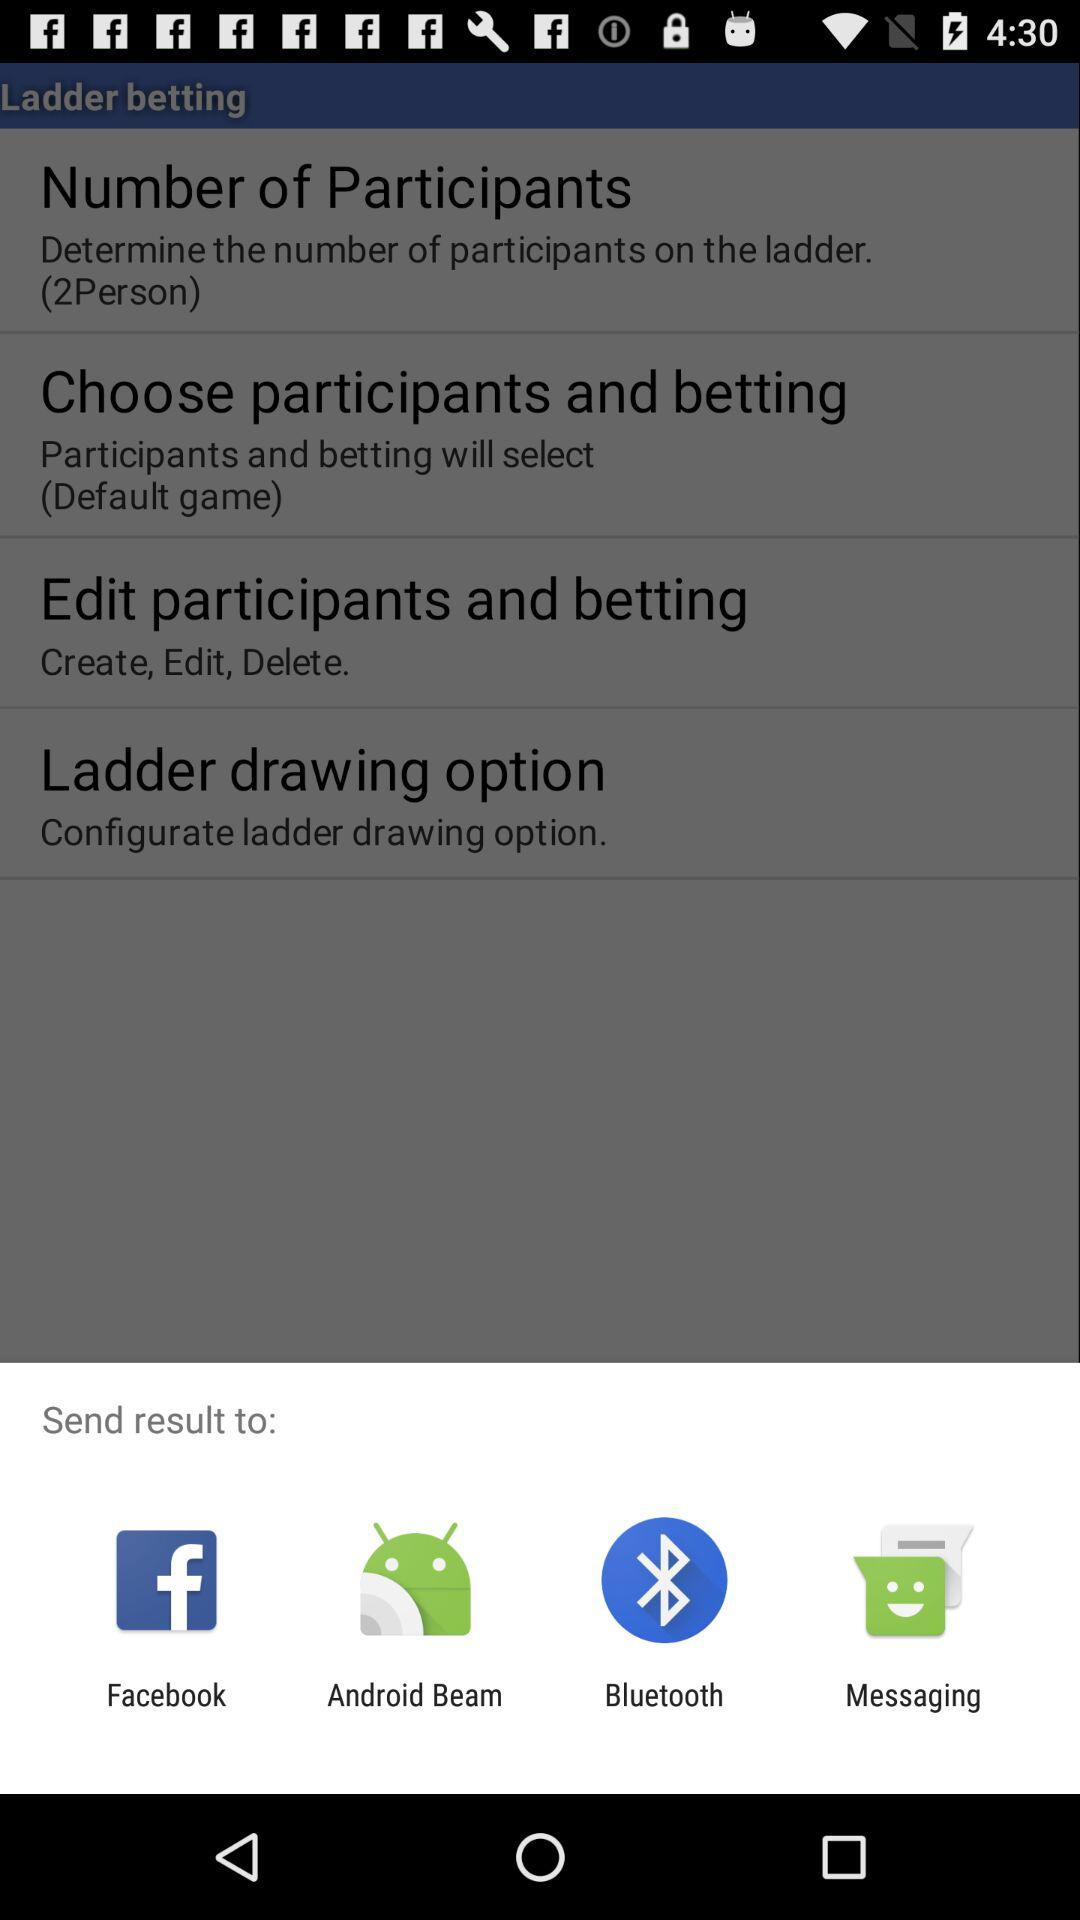What are the sharing options? The sharing options are "Facebook", "Android Beam", "Bluetooth" and "Messaging". 